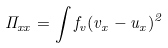<formula> <loc_0><loc_0><loc_500><loc_500>\Pi _ { x x } = \int f _ { v } ( v _ { x } - u _ { x } ) ^ { 2 }</formula> 